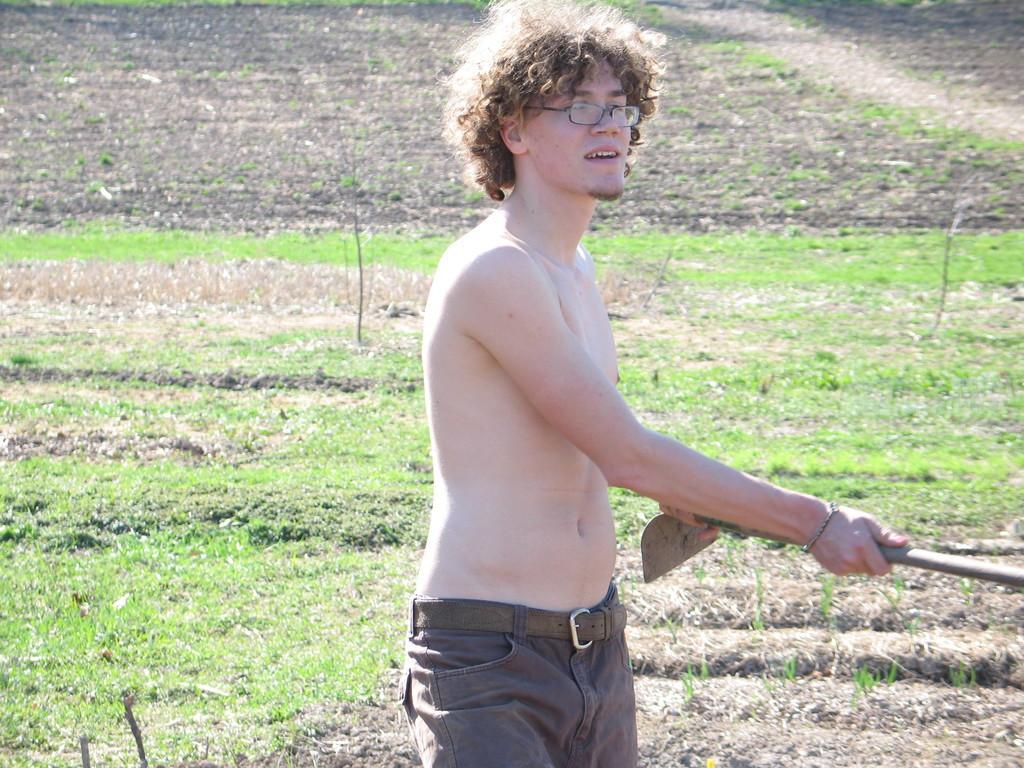Please provide a concise description of this image. In this image we can see a person holding a object in his hand. At the bottom of the image there is grass. 